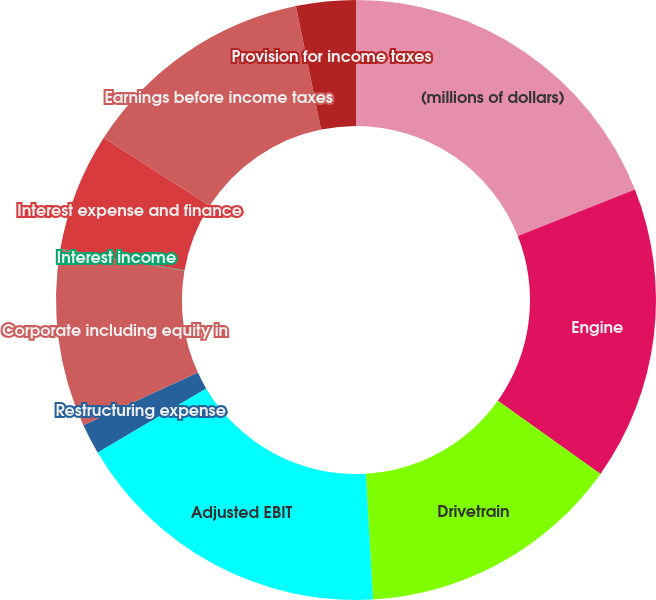<chart> <loc_0><loc_0><loc_500><loc_500><pie_chart><fcel>(millions of dollars)<fcel>Engine<fcel>Drivetrain<fcel>Adjusted EBIT<fcel>Restructuring expense<fcel>Corporate including equity in<fcel>Interest income<fcel>Interest expense and finance<fcel>Earnings before income taxes<fcel>Provision for income taxes<nl><fcel>19.0%<fcel>15.84%<fcel>14.26%<fcel>17.42%<fcel>1.63%<fcel>9.53%<fcel>0.05%<fcel>6.37%<fcel>12.69%<fcel>3.21%<nl></chart> 